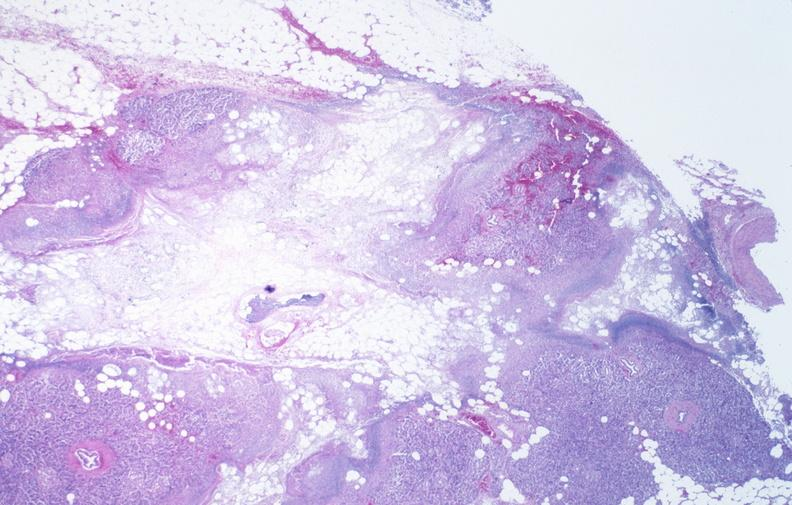where is this?
Answer the question using a single word or phrase. Pancreas 